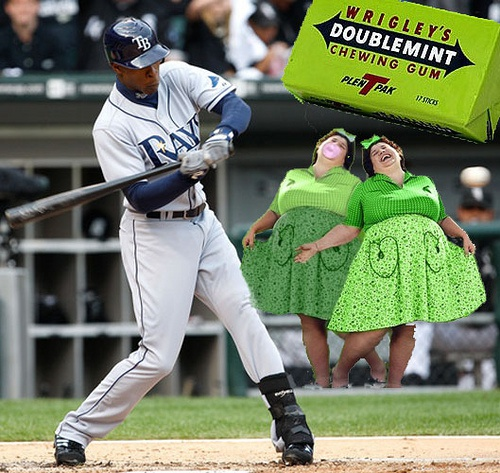Describe the objects in this image and their specific colors. I can see people in black, lightgray, darkgray, and gray tones, people in black, lightgreen, and green tones, people in black, green, darkgreen, and lightgreen tones, people in black, gray, and salmon tones, and baseball bat in black, darkgray, and gray tones in this image. 